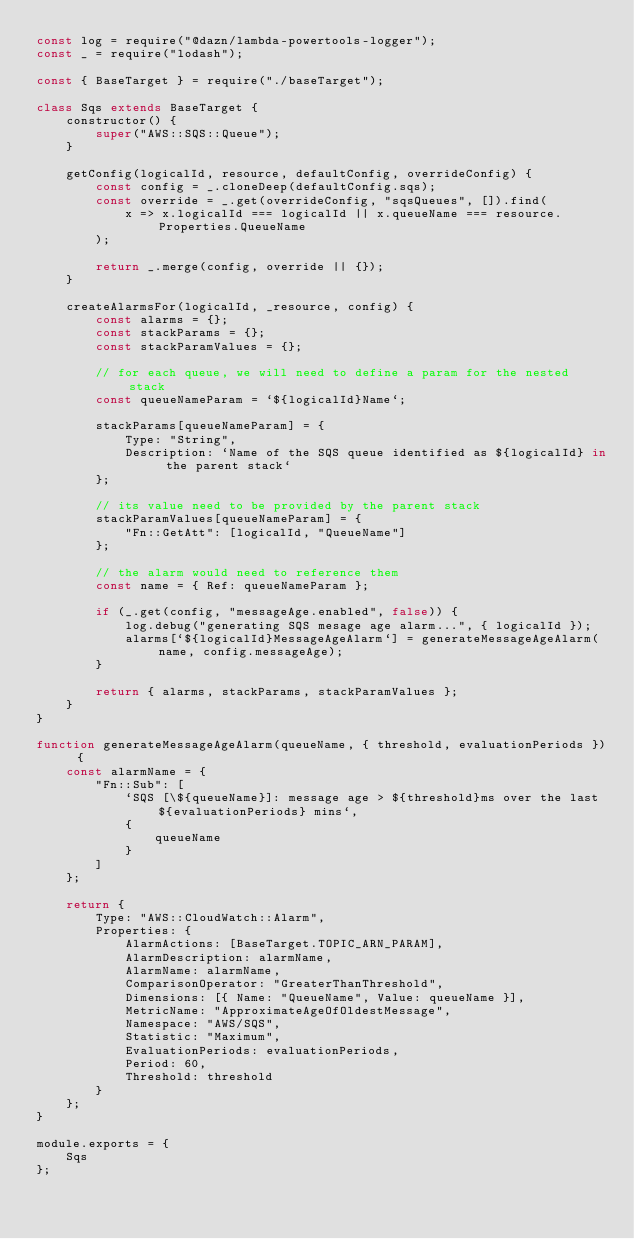<code> <loc_0><loc_0><loc_500><loc_500><_JavaScript_>const log = require("@dazn/lambda-powertools-logger");
const _ = require("lodash");

const { BaseTarget } = require("./baseTarget");

class Sqs extends BaseTarget {
	constructor() {
		super("AWS::SQS::Queue");
	}

	getConfig(logicalId, resource, defaultConfig, overrideConfig) {
		const config = _.cloneDeep(defaultConfig.sqs);
		const override = _.get(overrideConfig, "sqsQueues", []).find(
			x => x.logicalId === logicalId || x.queueName === resource.Properties.QueueName
		);

		return _.merge(config, override || {});
	}

	createAlarmsFor(logicalId, _resource, config) {
		const alarms = {};
		const stackParams = {};
		const stackParamValues = {};

		// for each queue, we will need to define a param for the nested stack
		const queueNameParam = `${logicalId}Name`;

		stackParams[queueNameParam] = {
			Type: "String",
			Description: `Name of the SQS queue identified as ${logicalId} in the parent stack`
		};

		// its value need to be provided by the parent stack
		stackParamValues[queueNameParam] = {
			"Fn::GetAtt": [logicalId, "QueueName"]
		};

		// the alarm would need to reference them
		const name = { Ref: queueNameParam };

		if (_.get(config, "messageAge.enabled", false)) {
			log.debug("generating SQS mesage age alarm...", { logicalId });
			alarms[`${logicalId}MessageAgeAlarm`] = generateMessageAgeAlarm(name, config.messageAge);
		}

		return { alarms, stackParams, stackParamValues };
	}
}

function generateMessageAgeAlarm(queueName, { threshold, evaluationPeriods }) {
	const alarmName = {
		"Fn::Sub": [
			`SQS [\${queueName}]: message age > ${threshold}ms over the last ${evaluationPeriods} mins`,
			{
				queueName
			}
		]
	};

	return {
		Type: "AWS::CloudWatch::Alarm",
		Properties: {
			AlarmActions: [BaseTarget.TOPIC_ARN_PARAM],
			AlarmDescription: alarmName,
			AlarmName: alarmName,
			ComparisonOperator: "GreaterThanThreshold",
			Dimensions: [{ Name: "QueueName", Value: queueName }],
			MetricName: "ApproximateAgeOfOldestMessage",
			Namespace: "AWS/SQS",
			Statistic: "Maximum",
			EvaluationPeriods: evaluationPeriods,
			Period: 60,
			Threshold: threshold
		}
	};
}

module.exports = {
	Sqs
};
</code> 